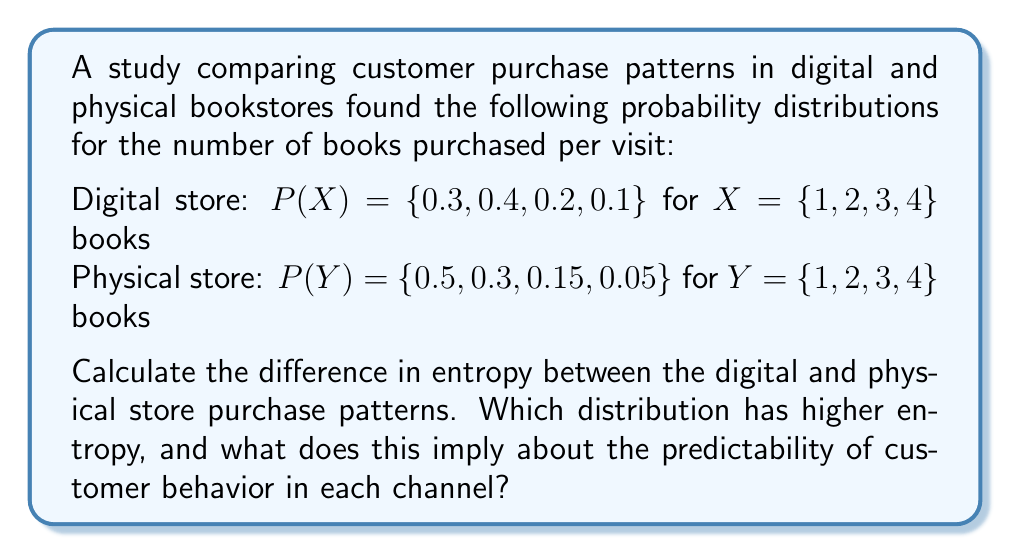Help me with this question. To solve this problem, we need to calculate the entropy for both the digital and physical store distributions, then compare them. The entropy of a discrete probability distribution is given by the formula:

$$ H(X) = -\sum_{i=1}^{n} p(x_i) \log_2 p(x_i) $$

Where $p(x_i)$ is the probability of each outcome.

1. Calculate entropy for the digital store:

$$ \begin{align*}
H(X) &= -[0.3 \log_2(0.3) + 0.4 \log_2(0.4) + 0.2 \log_2(0.2) + 0.1 \log_2(0.1)] \\
&= -[0.3 \cdot (-1.737) + 0.4 \cdot (-1.322) + 0.2 \cdot (-2.322) + 0.1 \cdot (-3.322)] \\
&= 0.521 + 0.529 + 0.464 + 0.332 \\
&= 1.846 \text{ bits}
\end{align*} $$

2. Calculate entropy for the physical store:

$$ \begin{align*}
H(Y) &= -[0.5 \log_2(0.5) + 0.3 \log_2(0.3) + 0.15 \log_2(0.15) + 0.05 \log_2(0.05)] \\
&= -[0.5 \cdot (-1) + 0.3 \cdot (-1.737) + 0.15 \cdot (-2.737) + 0.05 \cdot (-4.322)] \\
&= 0.5 + 0.521 + 0.411 + 0.216 \\
&= 1.648 \text{ bits}
\end{align*} $$

3. Calculate the difference in entropy:

$$ \Delta H = H(X) - H(Y) = 1.846 - 1.648 = 0.198 \text{ bits} $$

The digital store distribution has higher entropy. This implies that the customer behavior in the digital store is less predictable or more random than in the physical store. In information theory, higher entropy indicates more uncertainty or unpredictability in the outcomes.

For retail evolution, this suggests that customer purchasing patterns in digital stores may be more diverse or less constrained than in physical stores. Factors such as easier browsing, personalized recommendations, or a wider selection in digital stores could contribute to this increased variability in purchase behavior.
Answer: The difference in entropy between the digital and physical store purchase patterns is 0.198 bits, with the digital store having higher entropy (1.846 bits) compared to the physical store (1.648 bits). This implies that customer behavior in the digital store is less predictable than in the physical store. 